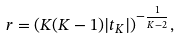<formula> <loc_0><loc_0><loc_500><loc_500>r = ( K ( K - 1 ) | t _ { K } | ) ^ { - \frac { 1 } { K - 2 } } ,</formula> 